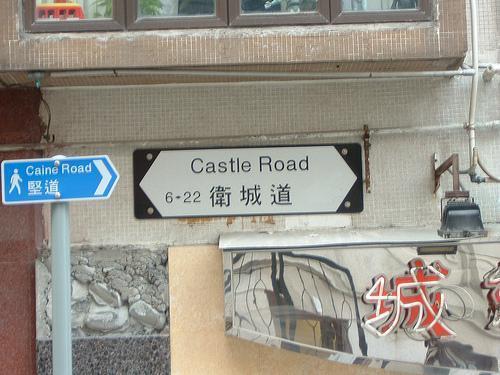How many blue signs are in the photo?
Give a very brief answer. 1. How many black and white signs are in the picture?
Give a very brief answer. 1. 